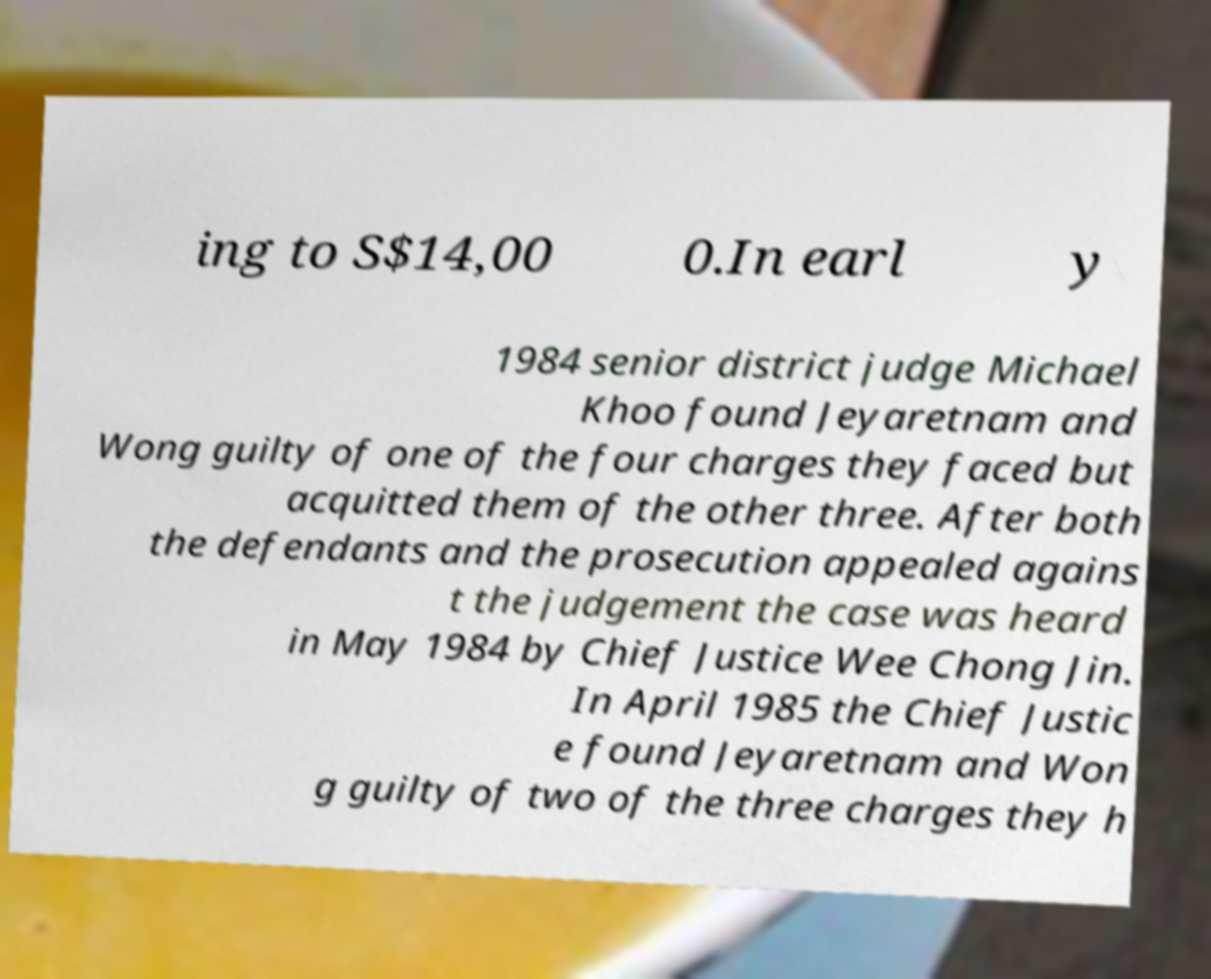Please identify and transcribe the text found in this image. ing to S$14,00 0.In earl y 1984 senior district judge Michael Khoo found Jeyaretnam and Wong guilty of one of the four charges they faced but acquitted them of the other three. After both the defendants and the prosecution appealed agains t the judgement the case was heard in May 1984 by Chief Justice Wee Chong Jin. In April 1985 the Chief Justic e found Jeyaretnam and Won g guilty of two of the three charges they h 